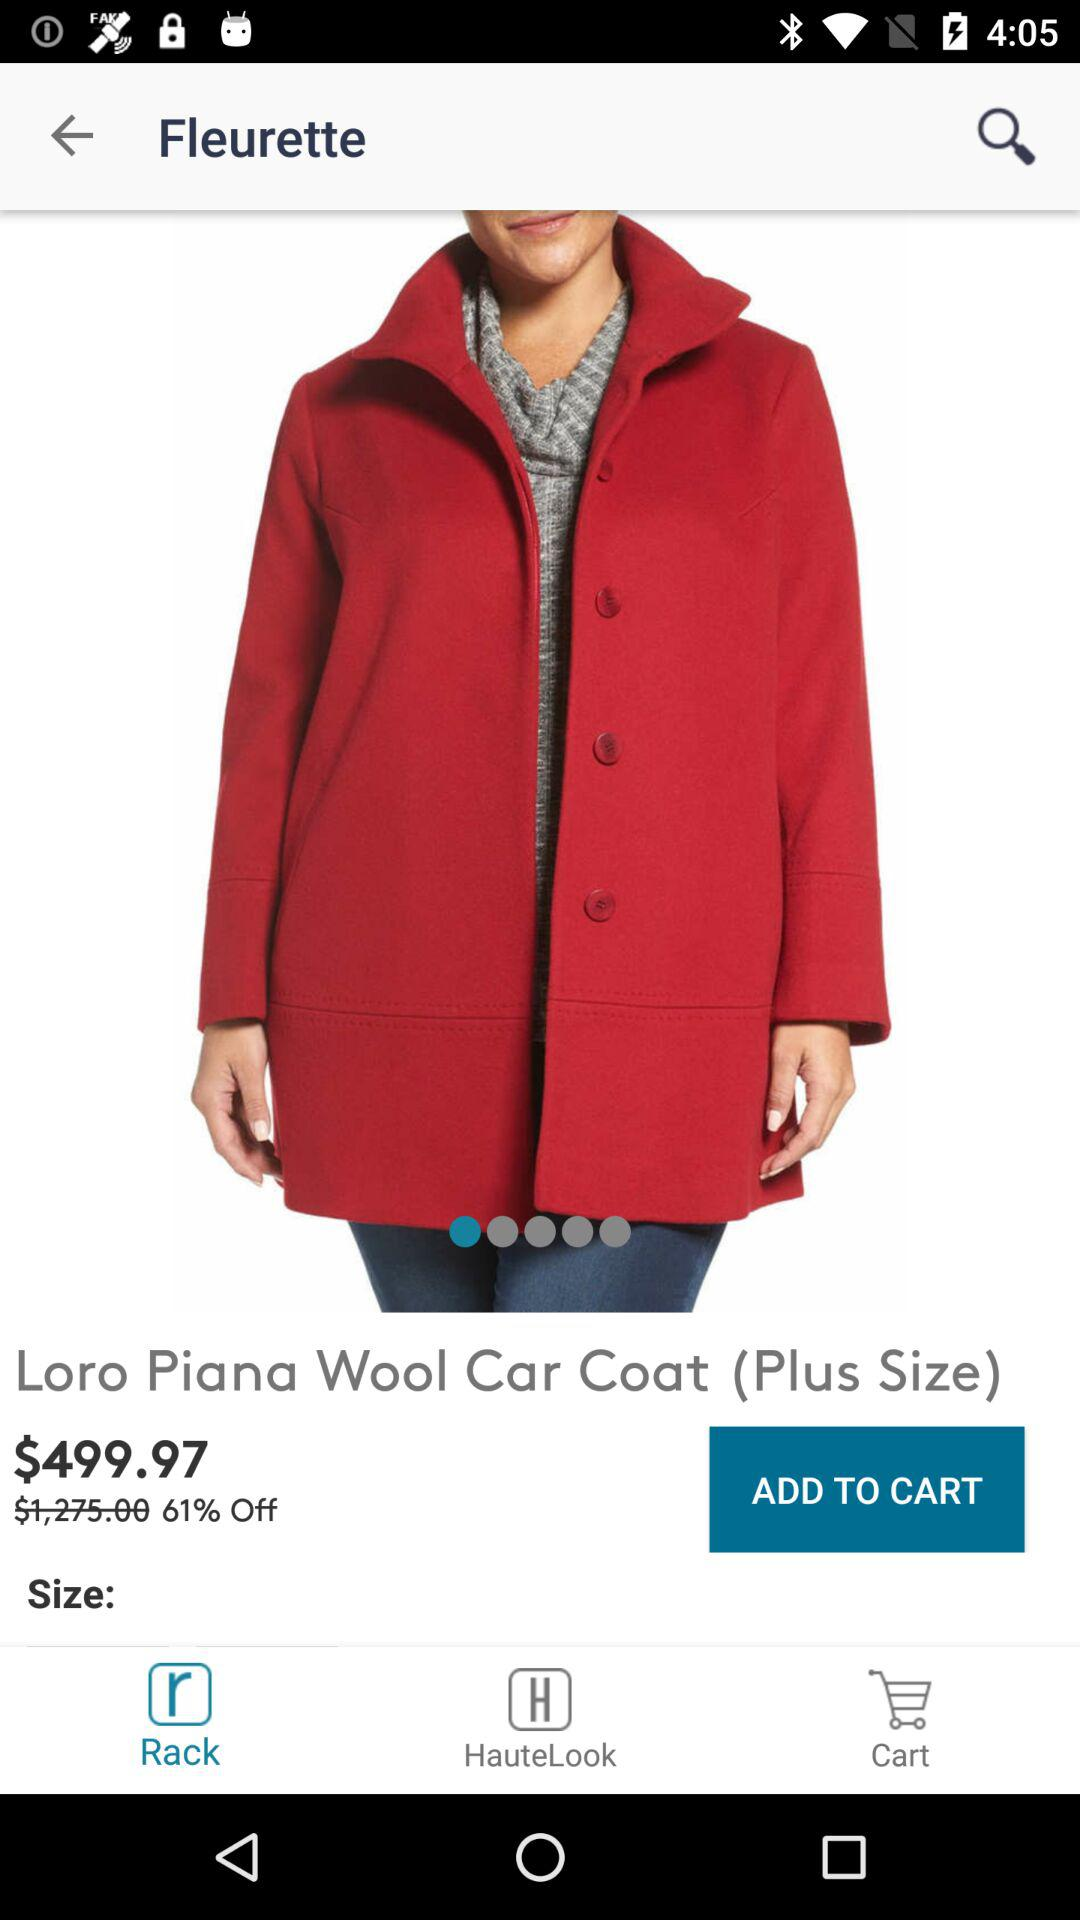What is the name of the product? The name of the product is "Loro Piana Wool Car Coat". 